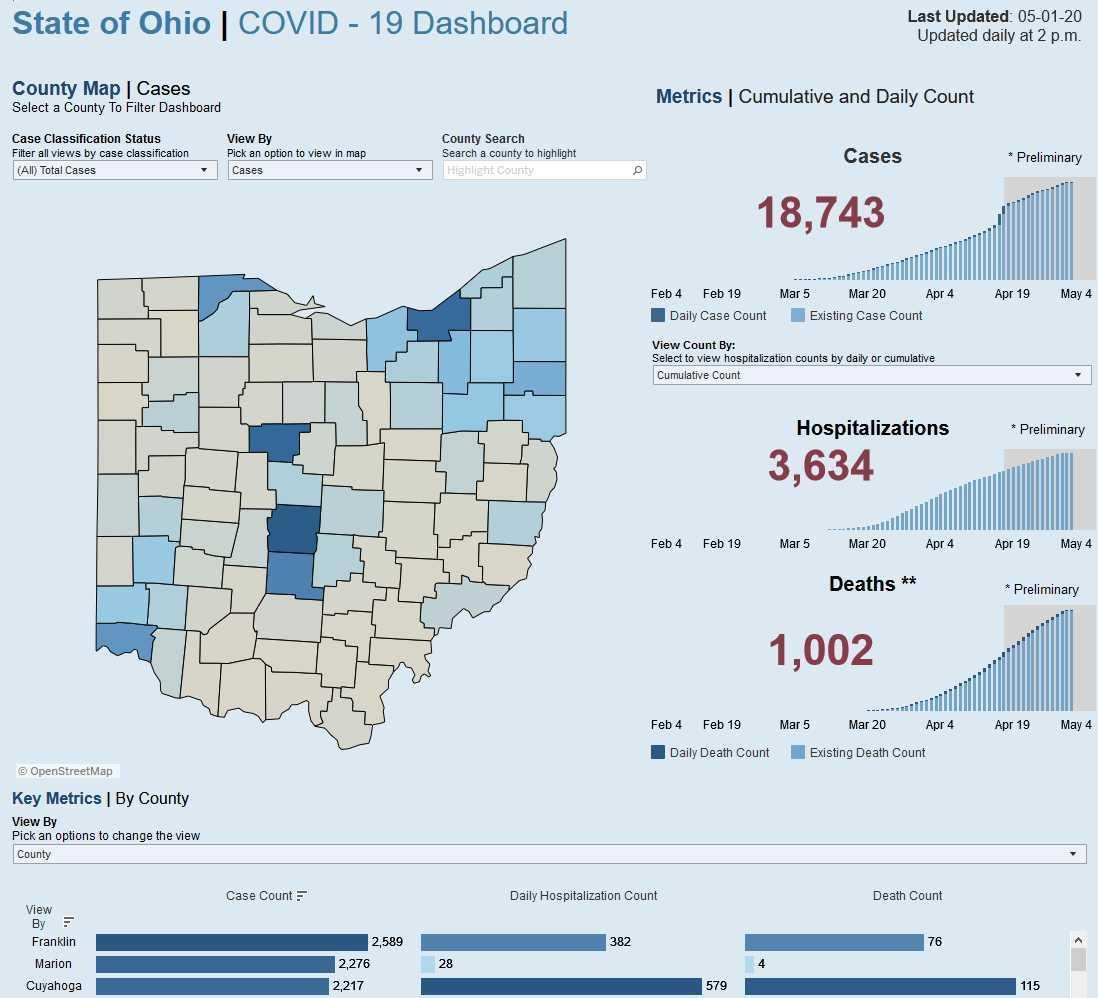What is the total number of deaths?
Answer the question with a short phrase. 1,002 By how much, is the total Hospitalizations higher than the total deaths? 2,632 What is the death count in Marion county? 4 What is the Daily hospitalization count in Cuyahoga county? 579 How much is the Case count in Franklin higher than that of Marion? 313 By how much is the case count in Marion county higher than Cuyahoga? 59 Which county has the highest Daily hospitalization count? Cuyahoga Which county has the highest Death count? Cuyahoga By how many 'times', is the Daily hospitalization count of Marion county higher than its death count? 7 By how much is the Death count in Cuyahoga County higher than Franklin county? 39 